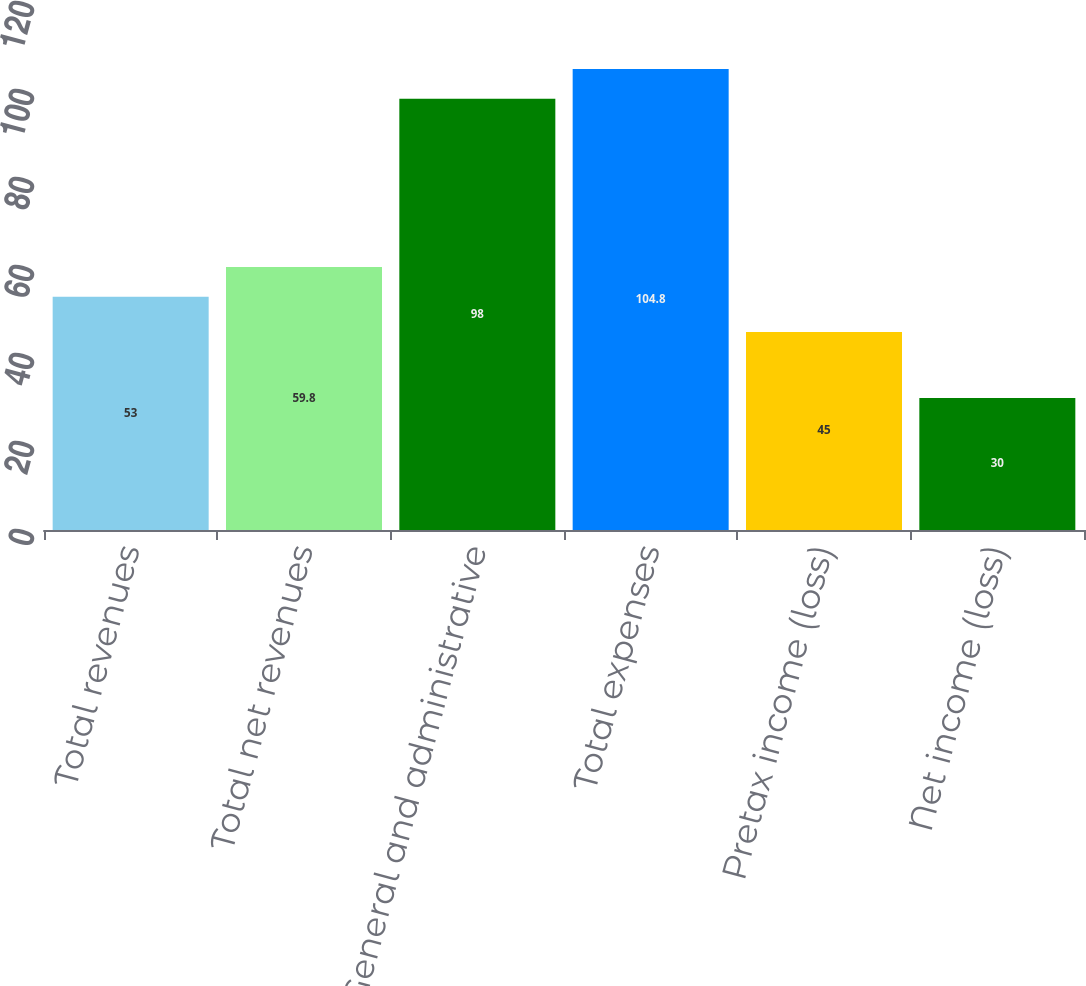<chart> <loc_0><loc_0><loc_500><loc_500><bar_chart><fcel>Total revenues<fcel>Total net revenues<fcel>General and administrative<fcel>Total expenses<fcel>Pretax income (loss)<fcel>Net income (loss)<nl><fcel>53<fcel>59.8<fcel>98<fcel>104.8<fcel>45<fcel>30<nl></chart> 